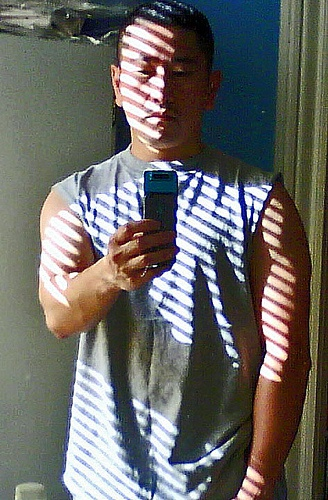Describe the objects in this image and their specific colors. I can see people in darkgreen, black, white, maroon, and gray tones and cell phone in darkgreen, black, navy, teal, and darkblue tones in this image. 